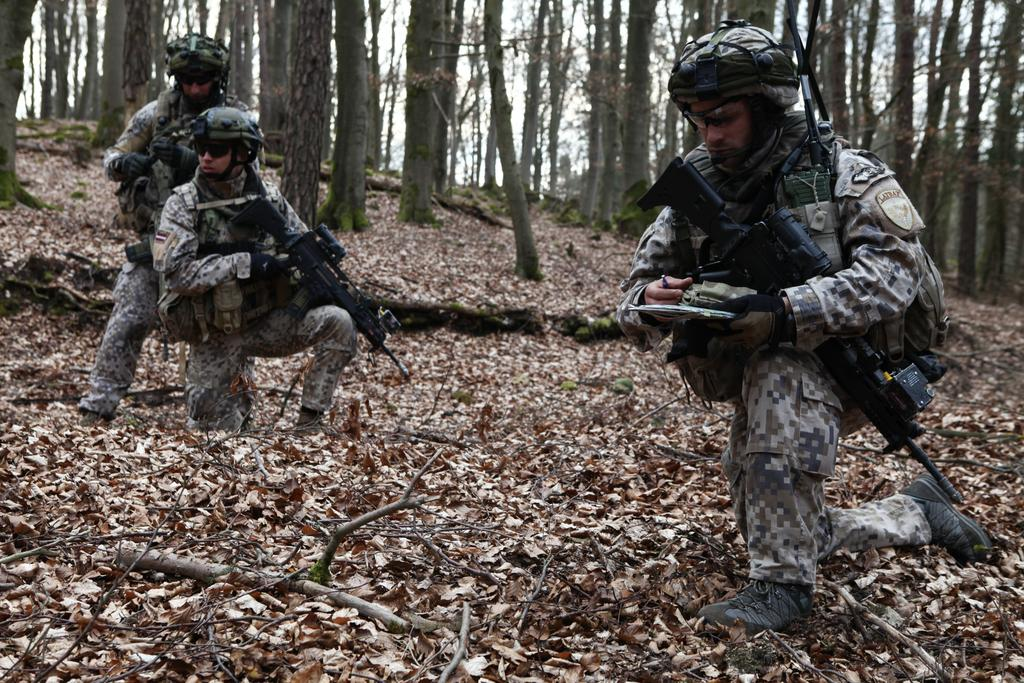What are the people in the image holding? The people in the image are holding guns. What is covering the ground in the image? The ground is covered with leaves and some wood. What type of natural environment is depicted in the image? There are trees in the image, indicating a forest or wooded area. What can be seen in the sky in the image? The sky is visible in the image. What advice is the person with the gun giving to the person holding the twig in the image? There is no person holding a twig in the image, and no advice is being given. 